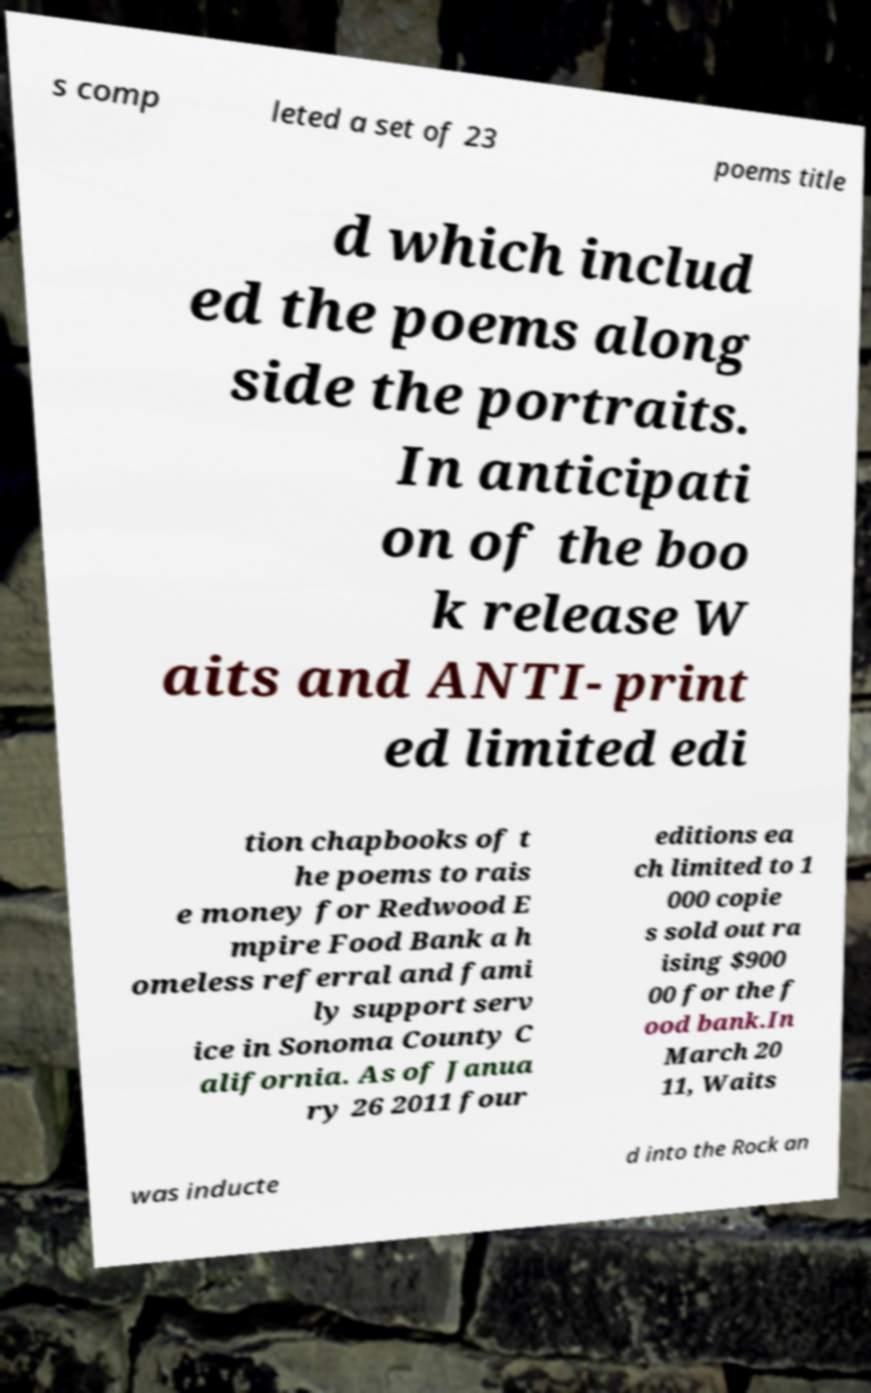For documentation purposes, I need the text within this image transcribed. Could you provide that? s comp leted a set of 23 poems title d which includ ed the poems along side the portraits. In anticipati on of the boo k release W aits and ANTI- print ed limited edi tion chapbooks of t he poems to rais e money for Redwood E mpire Food Bank a h omeless referral and fami ly support serv ice in Sonoma County C alifornia. As of Janua ry 26 2011 four editions ea ch limited to 1 000 copie s sold out ra ising $900 00 for the f ood bank.In March 20 11, Waits was inducte d into the Rock an 